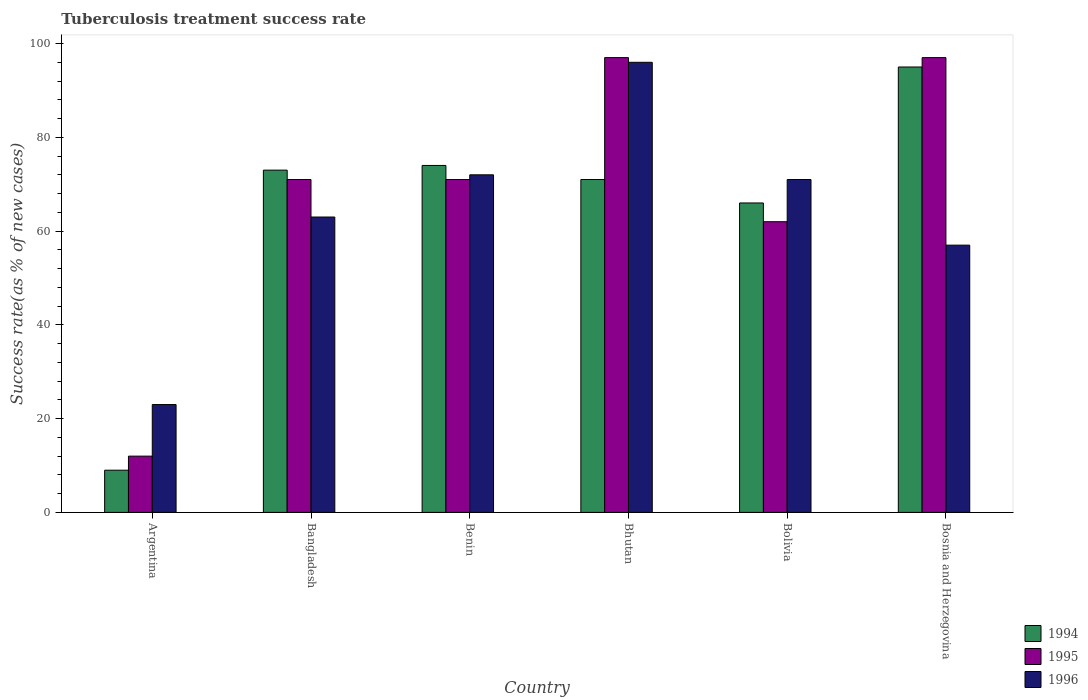How many different coloured bars are there?
Your answer should be compact. 3. Are the number of bars on each tick of the X-axis equal?
Ensure brevity in your answer.  Yes. In how many cases, is the number of bars for a given country not equal to the number of legend labels?
Offer a terse response. 0. What is the tuberculosis treatment success rate in 1995 in Bosnia and Herzegovina?
Your response must be concise. 97. Across all countries, what is the minimum tuberculosis treatment success rate in 1995?
Your answer should be very brief. 12. In which country was the tuberculosis treatment success rate in 1995 maximum?
Provide a succinct answer. Bhutan. What is the total tuberculosis treatment success rate in 1994 in the graph?
Your response must be concise. 388. What is the difference between the tuberculosis treatment success rate in 1996 in Argentina and that in Bangladesh?
Your answer should be very brief. -40. What is the difference between the tuberculosis treatment success rate in 1996 in Benin and the tuberculosis treatment success rate in 1995 in Bangladesh?
Ensure brevity in your answer.  1. What is the average tuberculosis treatment success rate in 1996 per country?
Ensure brevity in your answer.  63.67. What is the difference between the tuberculosis treatment success rate of/in 1996 and tuberculosis treatment success rate of/in 1994 in Bhutan?
Your response must be concise. 25. In how many countries, is the tuberculosis treatment success rate in 1996 greater than 20 %?
Ensure brevity in your answer.  6. What is the ratio of the tuberculosis treatment success rate in 1994 in Bangladesh to that in Bosnia and Herzegovina?
Offer a very short reply. 0.77. Is the difference between the tuberculosis treatment success rate in 1996 in Bangladesh and Benin greater than the difference between the tuberculosis treatment success rate in 1994 in Bangladesh and Benin?
Provide a short and direct response. No. In how many countries, is the tuberculosis treatment success rate in 1994 greater than the average tuberculosis treatment success rate in 1994 taken over all countries?
Make the answer very short. 5. Is the sum of the tuberculosis treatment success rate in 1995 in Bhutan and Bosnia and Herzegovina greater than the maximum tuberculosis treatment success rate in 1994 across all countries?
Keep it short and to the point. Yes. Is it the case that in every country, the sum of the tuberculosis treatment success rate in 1995 and tuberculosis treatment success rate in 1996 is greater than the tuberculosis treatment success rate in 1994?
Provide a succinct answer. Yes. Are all the bars in the graph horizontal?
Give a very brief answer. No. How many countries are there in the graph?
Offer a terse response. 6. Does the graph contain any zero values?
Give a very brief answer. No. Does the graph contain grids?
Offer a very short reply. No. Where does the legend appear in the graph?
Offer a very short reply. Bottom right. How are the legend labels stacked?
Make the answer very short. Vertical. What is the title of the graph?
Keep it short and to the point. Tuberculosis treatment success rate. What is the label or title of the Y-axis?
Ensure brevity in your answer.  Success rate(as % of new cases). What is the Success rate(as % of new cases) in 1995 in Argentina?
Your response must be concise. 12. What is the Success rate(as % of new cases) in 1994 in Bangladesh?
Keep it short and to the point. 73. What is the Success rate(as % of new cases) in 1996 in Bangladesh?
Ensure brevity in your answer.  63. What is the Success rate(as % of new cases) of 1995 in Benin?
Offer a terse response. 71. What is the Success rate(as % of new cases) of 1996 in Benin?
Your response must be concise. 72. What is the Success rate(as % of new cases) of 1995 in Bhutan?
Offer a terse response. 97. What is the Success rate(as % of new cases) of 1996 in Bhutan?
Your answer should be very brief. 96. What is the Success rate(as % of new cases) in 1995 in Bolivia?
Your response must be concise. 62. What is the Success rate(as % of new cases) in 1996 in Bolivia?
Keep it short and to the point. 71. What is the Success rate(as % of new cases) of 1994 in Bosnia and Herzegovina?
Offer a terse response. 95. What is the Success rate(as % of new cases) in 1995 in Bosnia and Herzegovina?
Offer a terse response. 97. What is the Success rate(as % of new cases) of 1996 in Bosnia and Herzegovina?
Your answer should be very brief. 57. Across all countries, what is the maximum Success rate(as % of new cases) of 1994?
Your response must be concise. 95. Across all countries, what is the maximum Success rate(as % of new cases) of 1995?
Give a very brief answer. 97. Across all countries, what is the maximum Success rate(as % of new cases) in 1996?
Offer a terse response. 96. Across all countries, what is the minimum Success rate(as % of new cases) in 1994?
Provide a succinct answer. 9. Across all countries, what is the minimum Success rate(as % of new cases) of 1996?
Provide a short and direct response. 23. What is the total Success rate(as % of new cases) in 1994 in the graph?
Offer a very short reply. 388. What is the total Success rate(as % of new cases) in 1995 in the graph?
Your answer should be very brief. 410. What is the total Success rate(as % of new cases) of 1996 in the graph?
Your response must be concise. 382. What is the difference between the Success rate(as % of new cases) of 1994 in Argentina and that in Bangladesh?
Your answer should be very brief. -64. What is the difference between the Success rate(as % of new cases) in 1995 in Argentina and that in Bangladesh?
Your response must be concise. -59. What is the difference between the Success rate(as % of new cases) in 1996 in Argentina and that in Bangladesh?
Your answer should be very brief. -40. What is the difference between the Success rate(as % of new cases) in 1994 in Argentina and that in Benin?
Your answer should be very brief. -65. What is the difference between the Success rate(as % of new cases) of 1995 in Argentina and that in Benin?
Provide a short and direct response. -59. What is the difference between the Success rate(as % of new cases) in 1996 in Argentina and that in Benin?
Keep it short and to the point. -49. What is the difference between the Success rate(as % of new cases) of 1994 in Argentina and that in Bhutan?
Give a very brief answer. -62. What is the difference between the Success rate(as % of new cases) in 1995 in Argentina and that in Bhutan?
Make the answer very short. -85. What is the difference between the Success rate(as % of new cases) in 1996 in Argentina and that in Bhutan?
Keep it short and to the point. -73. What is the difference between the Success rate(as % of new cases) of 1994 in Argentina and that in Bolivia?
Make the answer very short. -57. What is the difference between the Success rate(as % of new cases) of 1995 in Argentina and that in Bolivia?
Your answer should be compact. -50. What is the difference between the Success rate(as % of new cases) of 1996 in Argentina and that in Bolivia?
Make the answer very short. -48. What is the difference between the Success rate(as % of new cases) of 1994 in Argentina and that in Bosnia and Herzegovina?
Offer a very short reply. -86. What is the difference between the Success rate(as % of new cases) in 1995 in Argentina and that in Bosnia and Herzegovina?
Your answer should be compact. -85. What is the difference between the Success rate(as % of new cases) of 1996 in Argentina and that in Bosnia and Herzegovina?
Keep it short and to the point. -34. What is the difference between the Success rate(as % of new cases) of 1995 in Bangladesh and that in Benin?
Ensure brevity in your answer.  0. What is the difference between the Success rate(as % of new cases) of 1996 in Bangladesh and that in Bhutan?
Offer a very short reply. -33. What is the difference between the Success rate(as % of new cases) in 1996 in Bangladesh and that in Bolivia?
Make the answer very short. -8. What is the difference between the Success rate(as % of new cases) in 1996 in Bangladesh and that in Bosnia and Herzegovina?
Provide a short and direct response. 6. What is the difference between the Success rate(as % of new cases) in 1995 in Benin and that in Bhutan?
Your answer should be compact. -26. What is the difference between the Success rate(as % of new cases) in 1996 in Benin and that in Bhutan?
Your answer should be compact. -24. What is the difference between the Success rate(as % of new cases) in 1995 in Benin and that in Bolivia?
Your answer should be compact. 9. What is the difference between the Success rate(as % of new cases) of 1996 in Benin and that in Bolivia?
Provide a succinct answer. 1. What is the difference between the Success rate(as % of new cases) in 1994 in Benin and that in Bosnia and Herzegovina?
Your answer should be very brief. -21. What is the difference between the Success rate(as % of new cases) of 1996 in Benin and that in Bosnia and Herzegovina?
Offer a very short reply. 15. What is the difference between the Success rate(as % of new cases) in 1994 in Bhutan and that in Bolivia?
Ensure brevity in your answer.  5. What is the difference between the Success rate(as % of new cases) in 1995 in Bhutan and that in Bolivia?
Provide a short and direct response. 35. What is the difference between the Success rate(as % of new cases) in 1996 in Bhutan and that in Bolivia?
Keep it short and to the point. 25. What is the difference between the Success rate(as % of new cases) of 1996 in Bhutan and that in Bosnia and Herzegovina?
Provide a succinct answer. 39. What is the difference between the Success rate(as % of new cases) in 1995 in Bolivia and that in Bosnia and Herzegovina?
Your answer should be very brief. -35. What is the difference between the Success rate(as % of new cases) of 1994 in Argentina and the Success rate(as % of new cases) of 1995 in Bangladesh?
Offer a terse response. -62. What is the difference between the Success rate(as % of new cases) of 1994 in Argentina and the Success rate(as % of new cases) of 1996 in Bangladesh?
Provide a short and direct response. -54. What is the difference between the Success rate(as % of new cases) of 1995 in Argentina and the Success rate(as % of new cases) of 1996 in Bangladesh?
Your response must be concise. -51. What is the difference between the Success rate(as % of new cases) in 1994 in Argentina and the Success rate(as % of new cases) in 1995 in Benin?
Give a very brief answer. -62. What is the difference between the Success rate(as % of new cases) of 1994 in Argentina and the Success rate(as % of new cases) of 1996 in Benin?
Your answer should be very brief. -63. What is the difference between the Success rate(as % of new cases) in 1995 in Argentina and the Success rate(as % of new cases) in 1996 in Benin?
Keep it short and to the point. -60. What is the difference between the Success rate(as % of new cases) in 1994 in Argentina and the Success rate(as % of new cases) in 1995 in Bhutan?
Offer a very short reply. -88. What is the difference between the Success rate(as % of new cases) in 1994 in Argentina and the Success rate(as % of new cases) in 1996 in Bhutan?
Make the answer very short. -87. What is the difference between the Success rate(as % of new cases) of 1995 in Argentina and the Success rate(as % of new cases) of 1996 in Bhutan?
Provide a succinct answer. -84. What is the difference between the Success rate(as % of new cases) in 1994 in Argentina and the Success rate(as % of new cases) in 1995 in Bolivia?
Offer a terse response. -53. What is the difference between the Success rate(as % of new cases) of 1994 in Argentina and the Success rate(as % of new cases) of 1996 in Bolivia?
Provide a short and direct response. -62. What is the difference between the Success rate(as % of new cases) in 1995 in Argentina and the Success rate(as % of new cases) in 1996 in Bolivia?
Ensure brevity in your answer.  -59. What is the difference between the Success rate(as % of new cases) of 1994 in Argentina and the Success rate(as % of new cases) of 1995 in Bosnia and Herzegovina?
Ensure brevity in your answer.  -88. What is the difference between the Success rate(as % of new cases) in 1994 in Argentina and the Success rate(as % of new cases) in 1996 in Bosnia and Herzegovina?
Your response must be concise. -48. What is the difference between the Success rate(as % of new cases) in 1995 in Argentina and the Success rate(as % of new cases) in 1996 in Bosnia and Herzegovina?
Offer a terse response. -45. What is the difference between the Success rate(as % of new cases) of 1994 in Bangladesh and the Success rate(as % of new cases) of 1995 in Benin?
Your answer should be very brief. 2. What is the difference between the Success rate(as % of new cases) in 1994 in Bangladesh and the Success rate(as % of new cases) in 1996 in Benin?
Your answer should be compact. 1. What is the difference between the Success rate(as % of new cases) in 1994 in Bangladesh and the Success rate(as % of new cases) in 1995 in Bhutan?
Your answer should be compact. -24. What is the difference between the Success rate(as % of new cases) of 1994 in Bangladesh and the Success rate(as % of new cases) of 1996 in Bhutan?
Make the answer very short. -23. What is the difference between the Success rate(as % of new cases) in 1994 in Bangladesh and the Success rate(as % of new cases) in 1996 in Bosnia and Herzegovina?
Keep it short and to the point. 16. What is the difference between the Success rate(as % of new cases) in 1995 in Bangladesh and the Success rate(as % of new cases) in 1996 in Bosnia and Herzegovina?
Your answer should be very brief. 14. What is the difference between the Success rate(as % of new cases) of 1994 in Benin and the Success rate(as % of new cases) of 1995 in Bolivia?
Your answer should be compact. 12. What is the difference between the Success rate(as % of new cases) in 1994 in Benin and the Success rate(as % of new cases) in 1995 in Bosnia and Herzegovina?
Ensure brevity in your answer.  -23. What is the difference between the Success rate(as % of new cases) of 1994 in Benin and the Success rate(as % of new cases) of 1996 in Bosnia and Herzegovina?
Offer a very short reply. 17. What is the difference between the Success rate(as % of new cases) of 1994 in Bhutan and the Success rate(as % of new cases) of 1995 in Bolivia?
Provide a succinct answer. 9. What is the difference between the Success rate(as % of new cases) in 1994 in Bhutan and the Success rate(as % of new cases) in 1996 in Bolivia?
Keep it short and to the point. 0. What is the difference between the Success rate(as % of new cases) of 1994 in Bhutan and the Success rate(as % of new cases) of 1995 in Bosnia and Herzegovina?
Your answer should be very brief. -26. What is the difference between the Success rate(as % of new cases) of 1994 in Bhutan and the Success rate(as % of new cases) of 1996 in Bosnia and Herzegovina?
Make the answer very short. 14. What is the difference between the Success rate(as % of new cases) of 1994 in Bolivia and the Success rate(as % of new cases) of 1995 in Bosnia and Herzegovina?
Ensure brevity in your answer.  -31. What is the average Success rate(as % of new cases) of 1994 per country?
Offer a very short reply. 64.67. What is the average Success rate(as % of new cases) of 1995 per country?
Offer a very short reply. 68.33. What is the average Success rate(as % of new cases) of 1996 per country?
Your response must be concise. 63.67. What is the difference between the Success rate(as % of new cases) of 1994 and Success rate(as % of new cases) of 1995 in Argentina?
Ensure brevity in your answer.  -3. What is the difference between the Success rate(as % of new cases) in 1994 and Success rate(as % of new cases) in 1996 in Argentina?
Ensure brevity in your answer.  -14. What is the difference between the Success rate(as % of new cases) of 1994 and Success rate(as % of new cases) of 1995 in Bangladesh?
Offer a terse response. 2. What is the difference between the Success rate(as % of new cases) of 1994 and Success rate(as % of new cases) of 1995 in Benin?
Your answer should be compact. 3. What is the difference between the Success rate(as % of new cases) of 1994 and Success rate(as % of new cases) of 1995 in Bolivia?
Your response must be concise. 4. What is the difference between the Success rate(as % of new cases) in 1994 and Success rate(as % of new cases) in 1996 in Bolivia?
Make the answer very short. -5. What is the difference between the Success rate(as % of new cases) of 1994 and Success rate(as % of new cases) of 1995 in Bosnia and Herzegovina?
Your answer should be compact. -2. What is the ratio of the Success rate(as % of new cases) in 1994 in Argentina to that in Bangladesh?
Your answer should be very brief. 0.12. What is the ratio of the Success rate(as % of new cases) in 1995 in Argentina to that in Bangladesh?
Provide a short and direct response. 0.17. What is the ratio of the Success rate(as % of new cases) of 1996 in Argentina to that in Bangladesh?
Provide a succinct answer. 0.37. What is the ratio of the Success rate(as % of new cases) in 1994 in Argentina to that in Benin?
Your answer should be compact. 0.12. What is the ratio of the Success rate(as % of new cases) of 1995 in Argentina to that in Benin?
Offer a very short reply. 0.17. What is the ratio of the Success rate(as % of new cases) of 1996 in Argentina to that in Benin?
Keep it short and to the point. 0.32. What is the ratio of the Success rate(as % of new cases) of 1994 in Argentina to that in Bhutan?
Ensure brevity in your answer.  0.13. What is the ratio of the Success rate(as % of new cases) in 1995 in Argentina to that in Bhutan?
Give a very brief answer. 0.12. What is the ratio of the Success rate(as % of new cases) in 1996 in Argentina to that in Bhutan?
Provide a short and direct response. 0.24. What is the ratio of the Success rate(as % of new cases) in 1994 in Argentina to that in Bolivia?
Make the answer very short. 0.14. What is the ratio of the Success rate(as % of new cases) of 1995 in Argentina to that in Bolivia?
Keep it short and to the point. 0.19. What is the ratio of the Success rate(as % of new cases) of 1996 in Argentina to that in Bolivia?
Your response must be concise. 0.32. What is the ratio of the Success rate(as % of new cases) of 1994 in Argentina to that in Bosnia and Herzegovina?
Provide a succinct answer. 0.09. What is the ratio of the Success rate(as % of new cases) in 1995 in Argentina to that in Bosnia and Herzegovina?
Your response must be concise. 0.12. What is the ratio of the Success rate(as % of new cases) in 1996 in Argentina to that in Bosnia and Herzegovina?
Offer a terse response. 0.4. What is the ratio of the Success rate(as % of new cases) of 1994 in Bangladesh to that in Benin?
Your answer should be compact. 0.99. What is the ratio of the Success rate(as % of new cases) of 1996 in Bangladesh to that in Benin?
Give a very brief answer. 0.88. What is the ratio of the Success rate(as % of new cases) of 1994 in Bangladesh to that in Bhutan?
Ensure brevity in your answer.  1.03. What is the ratio of the Success rate(as % of new cases) of 1995 in Bangladesh to that in Bhutan?
Your answer should be very brief. 0.73. What is the ratio of the Success rate(as % of new cases) in 1996 in Bangladesh to that in Bhutan?
Offer a very short reply. 0.66. What is the ratio of the Success rate(as % of new cases) in 1994 in Bangladesh to that in Bolivia?
Provide a short and direct response. 1.11. What is the ratio of the Success rate(as % of new cases) in 1995 in Bangladesh to that in Bolivia?
Your answer should be compact. 1.15. What is the ratio of the Success rate(as % of new cases) in 1996 in Bangladesh to that in Bolivia?
Ensure brevity in your answer.  0.89. What is the ratio of the Success rate(as % of new cases) of 1994 in Bangladesh to that in Bosnia and Herzegovina?
Provide a succinct answer. 0.77. What is the ratio of the Success rate(as % of new cases) of 1995 in Bangladesh to that in Bosnia and Herzegovina?
Offer a very short reply. 0.73. What is the ratio of the Success rate(as % of new cases) of 1996 in Bangladesh to that in Bosnia and Herzegovina?
Your answer should be very brief. 1.11. What is the ratio of the Success rate(as % of new cases) of 1994 in Benin to that in Bhutan?
Your answer should be very brief. 1.04. What is the ratio of the Success rate(as % of new cases) in 1995 in Benin to that in Bhutan?
Your answer should be compact. 0.73. What is the ratio of the Success rate(as % of new cases) in 1994 in Benin to that in Bolivia?
Give a very brief answer. 1.12. What is the ratio of the Success rate(as % of new cases) in 1995 in Benin to that in Bolivia?
Make the answer very short. 1.15. What is the ratio of the Success rate(as % of new cases) in 1996 in Benin to that in Bolivia?
Your answer should be very brief. 1.01. What is the ratio of the Success rate(as % of new cases) of 1994 in Benin to that in Bosnia and Herzegovina?
Keep it short and to the point. 0.78. What is the ratio of the Success rate(as % of new cases) of 1995 in Benin to that in Bosnia and Herzegovina?
Offer a very short reply. 0.73. What is the ratio of the Success rate(as % of new cases) in 1996 in Benin to that in Bosnia and Herzegovina?
Provide a short and direct response. 1.26. What is the ratio of the Success rate(as % of new cases) in 1994 in Bhutan to that in Bolivia?
Give a very brief answer. 1.08. What is the ratio of the Success rate(as % of new cases) in 1995 in Bhutan to that in Bolivia?
Keep it short and to the point. 1.56. What is the ratio of the Success rate(as % of new cases) in 1996 in Bhutan to that in Bolivia?
Offer a terse response. 1.35. What is the ratio of the Success rate(as % of new cases) in 1994 in Bhutan to that in Bosnia and Herzegovina?
Make the answer very short. 0.75. What is the ratio of the Success rate(as % of new cases) in 1995 in Bhutan to that in Bosnia and Herzegovina?
Make the answer very short. 1. What is the ratio of the Success rate(as % of new cases) of 1996 in Bhutan to that in Bosnia and Herzegovina?
Offer a terse response. 1.68. What is the ratio of the Success rate(as % of new cases) in 1994 in Bolivia to that in Bosnia and Herzegovina?
Offer a terse response. 0.69. What is the ratio of the Success rate(as % of new cases) of 1995 in Bolivia to that in Bosnia and Herzegovina?
Your answer should be compact. 0.64. What is the ratio of the Success rate(as % of new cases) in 1996 in Bolivia to that in Bosnia and Herzegovina?
Your answer should be very brief. 1.25. What is the difference between the highest and the second highest Success rate(as % of new cases) of 1996?
Offer a terse response. 24. What is the difference between the highest and the lowest Success rate(as % of new cases) of 1996?
Your answer should be very brief. 73. 